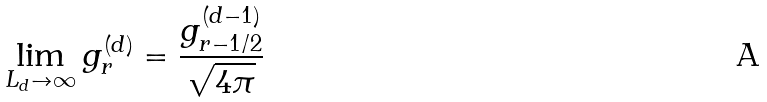Convert formula to latex. <formula><loc_0><loc_0><loc_500><loc_500>\lim _ { L _ { d } \to \infty } g ^ { ( d ) } _ { r } = \frac { g ^ { ( d - 1 ) } _ { r - 1 / 2 } } { \sqrt { 4 \pi } }</formula> 